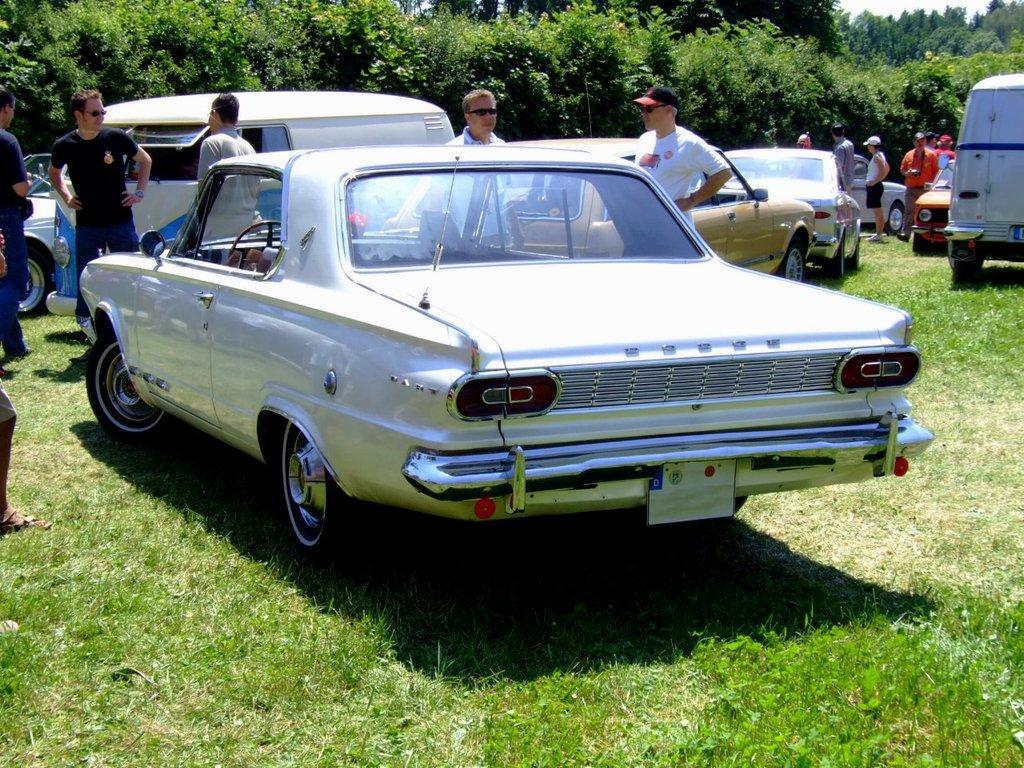Could you give a brief overview of what you see in this image? In this image there are cars. There are people standing on the grass. In the background of the image there are trees and sky. 